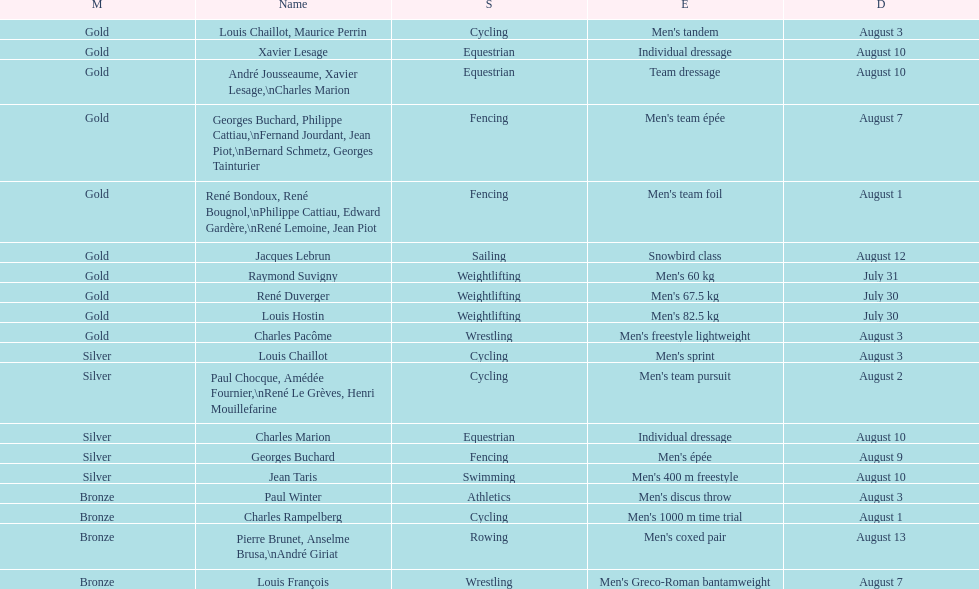In these olympics, what was this country's gold medal count? 10. 